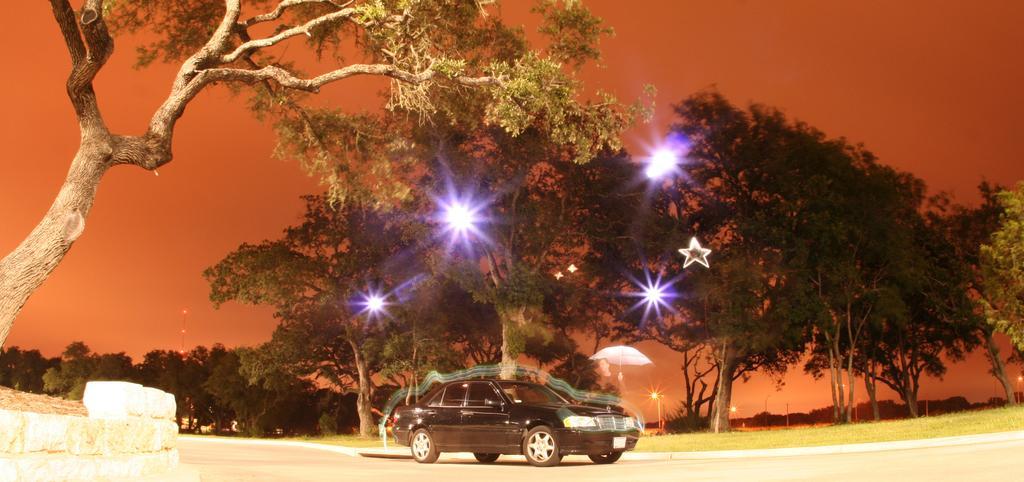Please provide a concise description of this image. In this picture I can see a car in front which is on the road and I see number of trees and in the center of this picture I see the lights and in the background I see the sky and I see the grass beside to the road. 